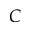Convert formula to latex. <formula><loc_0><loc_0><loc_500><loc_500>C</formula> 